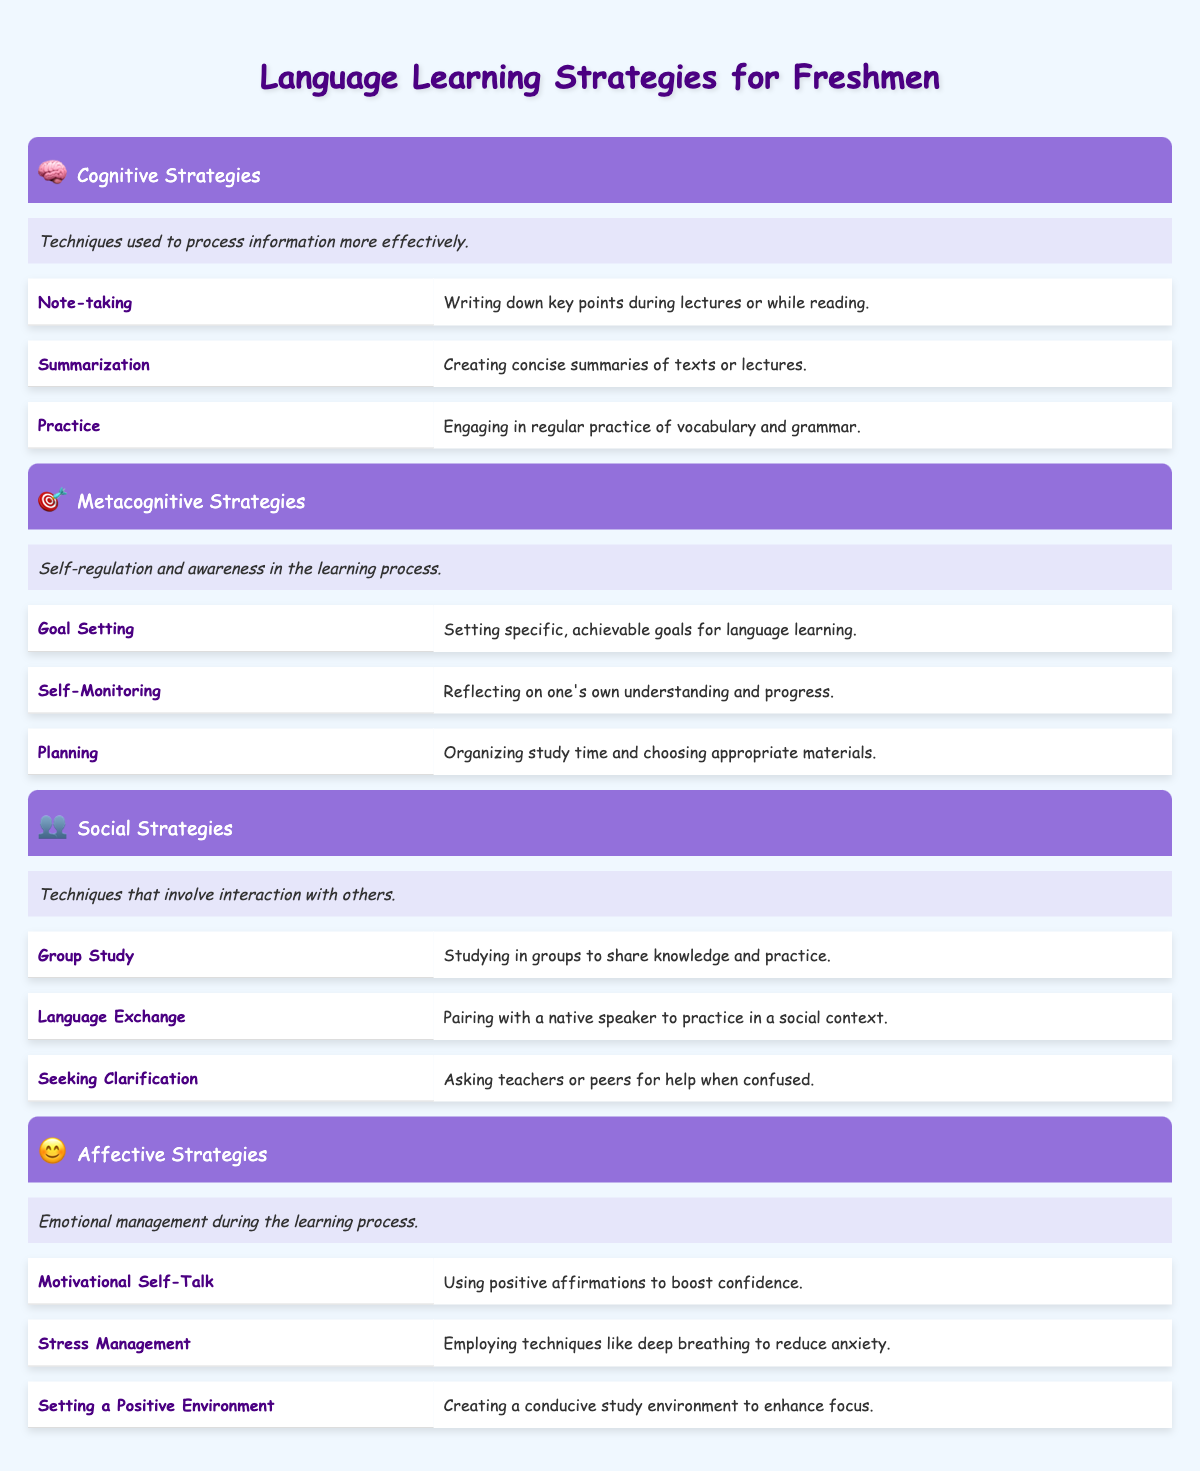What are cognitive strategies? Cognitive strategies are techniques used to process information more effectively. This definition can be found in the table under the cognitive strategies section.
Answer: Techniques used to process information more effectively Which example strategy involves writing down key points? The strategy that involves writing down key points during lectures or while reading is called "Note-taking." This can be directly referenced in the examples of cognitive strategies.
Answer: Note-taking How many total strategies are listed in the social strategies section? There are three strategies listed under the social strategies section: Group Study, Language Exchange, and Seeking Clarification. We count them directly from the table's social strategies examples.
Answer: 3 Does the affective strategies section include stress management? Yes, the affective strategies section does include "Stress Management" as one of its example strategies. This is clearly stated in the affective strategies examples in the table.
Answer: Yes What is the definition of metacognitive strategies? Metacognitive strategies are defined as self-regulation and awareness in the learning process. This definition is located in the metacognitive strategies section of the table.
Answer: Self-regulation and awareness in the learning process If a student uses all cognitive strategies, how many techniques will they employ? There are three cognitive strategies listed: Note-taking, Summarization, and Practice. Therefore, if a student uses all of them, they will employ three techniques.
Answer: 3 What strategy can help create a conducive study environment? The strategy that can help create a conducive study environment is "Setting a Positive Environment." This is found under the affective strategies examples in the table.
Answer: Setting a Positive Environment What is the relationship between self-monitoring and metacognitive strategies? Self-monitoring is one of the example strategies under metacognitive strategies, which indicates that self-monitoring is part of the broader category of self-regulation and awareness in learning. This relationship is directly observed in the table.
Answer: Self-monitoring is an example of metacognitive strategies Which strategy focuses on reflecting on one's own understanding? The strategy that focuses on reflecting on one's own understanding is "Self-Monitoring." This can be found in the metacognitive strategies section of the table.
Answer: Self-Monitoring 